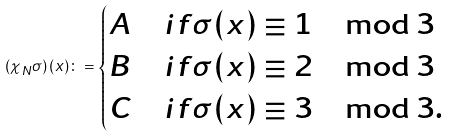Convert formula to latex. <formula><loc_0><loc_0><loc_500><loc_500>( \chi _ { N } \sigma ) \, ( x ) \colon = \begin{cases} A & i f \sigma ( x ) \equiv 1 \mod 3 \\ B & i f \sigma ( x ) \equiv 2 \mod 3 \\ C & i f \sigma ( x ) \equiv 3 \mod 3 . \end{cases}</formula> 